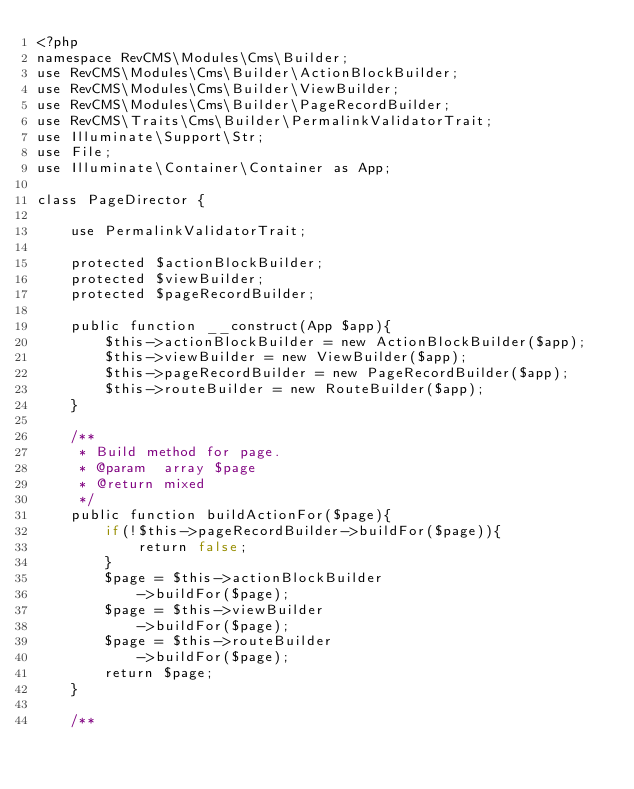<code> <loc_0><loc_0><loc_500><loc_500><_PHP_><?php 
namespace RevCMS\Modules\Cms\Builder;
use RevCMS\Modules\Cms\Builder\ActionBlockBuilder;
use RevCMS\Modules\Cms\Builder\ViewBuilder;
use RevCMS\Modules\Cms\Builder\PageRecordBuilder;
use RevCMS\Traits\Cms\Builder\PermalinkValidatorTrait;
use Illuminate\Support\Str;
use File;
use Illuminate\Container\Container as App;

class PageDirector {

	use PermalinkValidatorTrait;

	protected $actionBlockBuilder;
	protected $viewBuilder;
	protected $pageRecordBuilder;

	public function __construct(App $app){
		$this->actionBlockBuilder = new ActionBlockBuilder($app);
		$this->viewBuilder = new ViewBuilder($app);
		$this->pageRecordBuilder = new PageRecordBuilder($app);
		$this->routeBuilder = new RouteBuilder($app);
	}

	/**
	 * Build method for page.
	 * @param  array $page 
	 * @return mixed       
	 */
	public function buildActionFor($page){
		if(!$this->pageRecordBuilder->buildFor($page)){
			return false;
		}
		$page = $this->actionBlockBuilder
			->buildFor($page);
		$page = $this->viewBuilder
			->buildFor($page);
		$page = $this->routeBuilder
			->buildFor($page);
		return $page;
	}

	/**</code> 